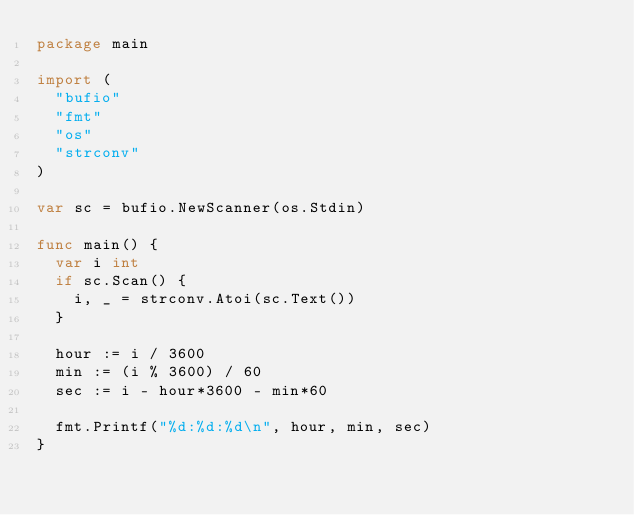<code> <loc_0><loc_0><loc_500><loc_500><_Go_>package main

import (
	"bufio"
	"fmt"
	"os"
	"strconv"
)

var sc = bufio.NewScanner(os.Stdin)

func main() {
	var i int
	if sc.Scan() {
		i, _ = strconv.Atoi(sc.Text())
	}

	hour := i / 3600
	min := (i % 3600) / 60
	sec := i - hour*3600 - min*60

	fmt.Printf("%d:%d:%d\n", hour, min, sec)
}

</code> 